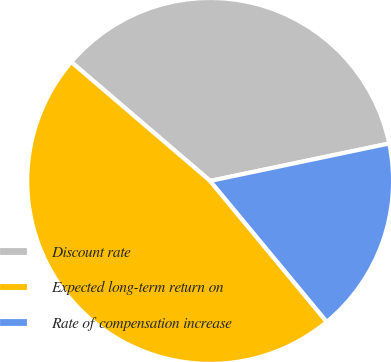Convert chart to OTSL. <chart><loc_0><loc_0><loc_500><loc_500><pie_chart><fcel>Discount rate<fcel>Expected long-term return on<fcel>Rate of compensation increase<nl><fcel>35.45%<fcel>47.27%<fcel>17.28%<nl></chart> 